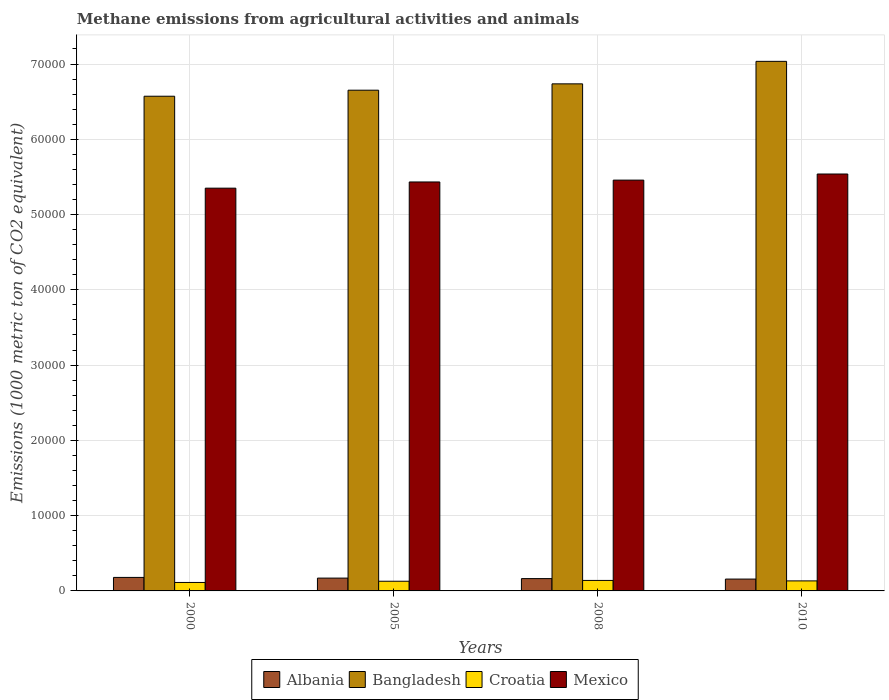How many different coloured bars are there?
Offer a terse response. 4. Are the number of bars per tick equal to the number of legend labels?
Your response must be concise. Yes. How many bars are there on the 1st tick from the left?
Make the answer very short. 4. How many bars are there on the 1st tick from the right?
Make the answer very short. 4. What is the label of the 4th group of bars from the left?
Ensure brevity in your answer.  2010. What is the amount of methane emitted in Croatia in 2005?
Your answer should be very brief. 1285.2. Across all years, what is the maximum amount of methane emitted in Croatia?
Offer a very short reply. 1392.8. Across all years, what is the minimum amount of methane emitted in Mexico?
Keep it short and to the point. 5.35e+04. In which year was the amount of methane emitted in Croatia maximum?
Your answer should be compact. 2008. In which year was the amount of methane emitted in Mexico minimum?
Keep it short and to the point. 2000. What is the total amount of methane emitted in Albania in the graph?
Offer a terse response. 6707.4. What is the difference between the amount of methane emitted in Croatia in 2008 and that in 2010?
Keep it short and to the point. 61.5. What is the difference between the amount of methane emitted in Mexico in 2008 and the amount of methane emitted in Bangladesh in 2010?
Your answer should be very brief. -1.58e+04. What is the average amount of methane emitted in Mexico per year?
Keep it short and to the point. 5.44e+04. In the year 2000, what is the difference between the amount of methane emitted in Croatia and amount of methane emitted in Mexico?
Give a very brief answer. -5.24e+04. In how many years, is the amount of methane emitted in Croatia greater than 36000 1000 metric ton?
Make the answer very short. 0. What is the ratio of the amount of methane emitted in Croatia in 2005 to that in 2010?
Your answer should be compact. 0.97. Is the amount of methane emitted in Croatia in 2000 less than that in 2008?
Your answer should be compact. Yes. What is the difference between the highest and the second highest amount of methane emitted in Bangladesh?
Your answer should be very brief. 2989. What is the difference between the highest and the lowest amount of methane emitted in Mexico?
Offer a very short reply. 1881.2. In how many years, is the amount of methane emitted in Croatia greater than the average amount of methane emitted in Croatia taken over all years?
Make the answer very short. 3. What does the 3rd bar from the left in 2008 represents?
Your answer should be compact. Croatia. What does the 3rd bar from the right in 2005 represents?
Make the answer very short. Bangladesh. Is it the case that in every year, the sum of the amount of methane emitted in Croatia and amount of methane emitted in Bangladesh is greater than the amount of methane emitted in Albania?
Your response must be concise. Yes. How many bars are there?
Provide a succinct answer. 16. How many years are there in the graph?
Your response must be concise. 4. Does the graph contain any zero values?
Offer a terse response. No. Does the graph contain grids?
Give a very brief answer. Yes. Where does the legend appear in the graph?
Make the answer very short. Bottom center. How many legend labels are there?
Ensure brevity in your answer.  4. What is the title of the graph?
Ensure brevity in your answer.  Methane emissions from agricultural activities and animals. Does "Burundi" appear as one of the legend labels in the graph?
Give a very brief answer. No. What is the label or title of the Y-axis?
Offer a very short reply. Emissions (1000 metric ton of CO2 equivalent). What is the Emissions (1000 metric ton of CO2 equivalent) in Albania in 2000?
Provide a short and direct response. 1794.6. What is the Emissions (1000 metric ton of CO2 equivalent) in Bangladesh in 2000?
Provide a short and direct response. 6.57e+04. What is the Emissions (1000 metric ton of CO2 equivalent) in Croatia in 2000?
Provide a short and direct response. 1124.5. What is the Emissions (1000 metric ton of CO2 equivalent) in Mexico in 2000?
Your answer should be compact. 5.35e+04. What is the Emissions (1000 metric ton of CO2 equivalent) of Albania in 2005?
Offer a very short reply. 1702.9. What is the Emissions (1000 metric ton of CO2 equivalent) of Bangladesh in 2005?
Your response must be concise. 6.65e+04. What is the Emissions (1000 metric ton of CO2 equivalent) in Croatia in 2005?
Make the answer very short. 1285.2. What is the Emissions (1000 metric ton of CO2 equivalent) in Mexico in 2005?
Give a very brief answer. 5.43e+04. What is the Emissions (1000 metric ton of CO2 equivalent) of Albania in 2008?
Offer a terse response. 1635.8. What is the Emissions (1000 metric ton of CO2 equivalent) of Bangladesh in 2008?
Provide a short and direct response. 6.74e+04. What is the Emissions (1000 metric ton of CO2 equivalent) of Croatia in 2008?
Offer a very short reply. 1392.8. What is the Emissions (1000 metric ton of CO2 equivalent) of Mexico in 2008?
Your answer should be very brief. 5.46e+04. What is the Emissions (1000 metric ton of CO2 equivalent) of Albania in 2010?
Provide a succinct answer. 1574.1. What is the Emissions (1000 metric ton of CO2 equivalent) of Bangladesh in 2010?
Ensure brevity in your answer.  7.04e+04. What is the Emissions (1000 metric ton of CO2 equivalent) of Croatia in 2010?
Offer a very short reply. 1331.3. What is the Emissions (1000 metric ton of CO2 equivalent) in Mexico in 2010?
Make the answer very short. 5.54e+04. Across all years, what is the maximum Emissions (1000 metric ton of CO2 equivalent) of Albania?
Your answer should be compact. 1794.6. Across all years, what is the maximum Emissions (1000 metric ton of CO2 equivalent) of Bangladesh?
Offer a terse response. 7.04e+04. Across all years, what is the maximum Emissions (1000 metric ton of CO2 equivalent) in Croatia?
Give a very brief answer. 1392.8. Across all years, what is the maximum Emissions (1000 metric ton of CO2 equivalent) of Mexico?
Provide a succinct answer. 5.54e+04. Across all years, what is the minimum Emissions (1000 metric ton of CO2 equivalent) of Albania?
Offer a very short reply. 1574.1. Across all years, what is the minimum Emissions (1000 metric ton of CO2 equivalent) of Bangladesh?
Offer a very short reply. 6.57e+04. Across all years, what is the minimum Emissions (1000 metric ton of CO2 equivalent) of Croatia?
Offer a terse response. 1124.5. Across all years, what is the minimum Emissions (1000 metric ton of CO2 equivalent) in Mexico?
Offer a terse response. 5.35e+04. What is the total Emissions (1000 metric ton of CO2 equivalent) of Albania in the graph?
Provide a short and direct response. 6707.4. What is the total Emissions (1000 metric ton of CO2 equivalent) in Bangladesh in the graph?
Your response must be concise. 2.70e+05. What is the total Emissions (1000 metric ton of CO2 equivalent) of Croatia in the graph?
Ensure brevity in your answer.  5133.8. What is the total Emissions (1000 metric ton of CO2 equivalent) in Mexico in the graph?
Make the answer very short. 2.18e+05. What is the difference between the Emissions (1000 metric ton of CO2 equivalent) of Albania in 2000 and that in 2005?
Your answer should be very brief. 91.7. What is the difference between the Emissions (1000 metric ton of CO2 equivalent) in Bangladesh in 2000 and that in 2005?
Keep it short and to the point. -800.9. What is the difference between the Emissions (1000 metric ton of CO2 equivalent) in Croatia in 2000 and that in 2005?
Keep it short and to the point. -160.7. What is the difference between the Emissions (1000 metric ton of CO2 equivalent) of Mexico in 2000 and that in 2005?
Your answer should be compact. -824. What is the difference between the Emissions (1000 metric ton of CO2 equivalent) of Albania in 2000 and that in 2008?
Your response must be concise. 158.8. What is the difference between the Emissions (1000 metric ton of CO2 equivalent) in Bangladesh in 2000 and that in 2008?
Provide a short and direct response. -1643.5. What is the difference between the Emissions (1000 metric ton of CO2 equivalent) of Croatia in 2000 and that in 2008?
Keep it short and to the point. -268.3. What is the difference between the Emissions (1000 metric ton of CO2 equivalent) in Mexico in 2000 and that in 2008?
Make the answer very short. -1070.7. What is the difference between the Emissions (1000 metric ton of CO2 equivalent) in Albania in 2000 and that in 2010?
Provide a short and direct response. 220.5. What is the difference between the Emissions (1000 metric ton of CO2 equivalent) of Bangladesh in 2000 and that in 2010?
Offer a terse response. -4632.5. What is the difference between the Emissions (1000 metric ton of CO2 equivalent) in Croatia in 2000 and that in 2010?
Ensure brevity in your answer.  -206.8. What is the difference between the Emissions (1000 metric ton of CO2 equivalent) in Mexico in 2000 and that in 2010?
Offer a terse response. -1881.2. What is the difference between the Emissions (1000 metric ton of CO2 equivalent) of Albania in 2005 and that in 2008?
Make the answer very short. 67.1. What is the difference between the Emissions (1000 metric ton of CO2 equivalent) in Bangladesh in 2005 and that in 2008?
Offer a terse response. -842.6. What is the difference between the Emissions (1000 metric ton of CO2 equivalent) in Croatia in 2005 and that in 2008?
Offer a very short reply. -107.6. What is the difference between the Emissions (1000 metric ton of CO2 equivalent) in Mexico in 2005 and that in 2008?
Give a very brief answer. -246.7. What is the difference between the Emissions (1000 metric ton of CO2 equivalent) of Albania in 2005 and that in 2010?
Provide a succinct answer. 128.8. What is the difference between the Emissions (1000 metric ton of CO2 equivalent) of Bangladesh in 2005 and that in 2010?
Give a very brief answer. -3831.6. What is the difference between the Emissions (1000 metric ton of CO2 equivalent) of Croatia in 2005 and that in 2010?
Offer a very short reply. -46.1. What is the difference between the Emissions (1000 metric ton of CO2 equivalent) in Mexico in 2005 and that in 2010?
Keep it short and to the point. -1057.2. What is the difference between the Emissions (1000 metric ton of CO2 equivalent) of Albania in 2008 and that in 2010?
Your answer should be compact. 61.7. What is the difference between the Emissions (1000 metric ton of CO2 equivalent) of Bangladesh in 2008 and that in 2010?
Your response must be concise. -2989. What is the difference between the Emissions (1000 metric ton of CO2 equivalent) in Croatia in 2008 and that in 2010?
Ensure brevity in your answer.  61.5. What is the difference between the Emissions (1000 metric ton of CO2 equivalent) of Mexico in 2008 and that in 2010?
Your response must be concise. -810.5. What is the difference between the Emissions (1000 metric ton of CO2 equivalent) in Albania in 2000 and the Emissions (1000 metric ton of CO2 equivalent) in Bangladesh in 2005?
Your response must be concise. -6.47e+04. What is the difference between the Emissions (1000 metric ton of CO2 equivalent) of Albania in 2000 and the Emissions (1000 metric ton of CO2 equivalent) of Croatia in 2005?
Provide a short and direct response. 509.4. What is the difference between the Emissions (1000 metric ton of CO2 equivalent) of Albania in 2000 and the Emissions (1000 metric ton of CO2 equivalent) of Mexico in 2005?
Provide a short and direct response. -5.25e+04. What is the difference between the Emissions (1000 metric ton of CO2 equivalent) of Bangladesh in 2000 and the Emissions (1000 metric ton of CO2 equivalent) of Croatia in 2005?
Your answer should be very brief. 6.44e+04. What is the difference between the Emissions (1000 metric ton of CO2 equivalent) of Bangladesh in 2000 and the Emissions (1000 metric ton of CO2 equivalent) of Mexico in 2005?
Keep it short and to the point. 1.14e+04. What is the difference between the Emissions (1000 metric ton of CO2 equivalent) in Croatia in 2000 and the Emissions (1000 metric ton of CO2 equivalent) in Mexico in 2005?
Give a very brief answer. -5.32e+04. What is the difference between the Emissions (1000 metric ton of CO2 equivalent) in Albania in 2000 and the Emissions (1000 metric ton of CO2 equivalent) in Bangladesh in 2008?
Your answer should be compact. -6.56e+04. What is the difference between the Emissions (1000 metric ton of CO2 equivalent) in Albania in 2000 and the Emissions (1000 metric ton of CO2 equivalent) in Croatia in 2008?
Ensure brevity in your answer.  401.8. What is the difference between the Emissions (1000 metric ton of CO2 equivalent) in Albania in 2000 and the Emissions (1000 metric ton of CO2 equivalent) in Mexico in 2008?
Keep it short and to the point. -5.28e+04. What is the difference between the Emissions (1000 metric ton of CO2 equivalent) of Bangladesh in 2000 and the Emissions (1000 metric ton of CO2 equivalent) of Croatia in 2008?
Offer a terse response. 6.43e+04. What is the difference between the Emissions (1000 metric ton of CO2 equivalent) of Bangladesh in 2000 and the Emissions (1000 metric ton of CO2 equivalent) of Mexico in 2008?
Offer a terse response. 1.11e+04. What is the difference between the Emissions (1000 metric ton of CO2 equivalent) of Croatia in 2000 and the Emissions (1000 metric ton of CO2 equivalent) of Mexico in 2008?
Make the answer very short. -5.35e+04. What is the difference between the Emissions (1000 metric ton of CO2 equivalent) in Albania in 2000 and the Emissions (1000 metric ton of CO2 equivalent) in Bangladesh in 2010?
Provide a short and direct response. -6.86e+04. What is the difference between the Emissions (1000 metric ton of CO2 equivalent) of Albania in 2000 and the Emissions (1000 metric ton of CO2 equivalent) of Croatia in 2010?
Provide a short and direct response. 463.3. What is the difference between the Emissions (1000 metric ton of CO2 equivalent) of Albania in 2000 and the Emissions (1000 metric ton of CO2 equivalent) of Mexico in 2010?
Offer a very short reply. -5.36e+04. What is the difference between the Emissions (1000 metric ton of CO2 equivalent) in Bangladesh in 2000 and the Emissions (1000 metric ton of CO2 equivalent) in Croatia in 2010?
Offer a terse response. 6.44e+04. What is the difference between the Emissions (1000 metric ton of CO2 equivalent) of Bangladesh in 2000 and the Emissions (1000 metric ton of CO2 equivalent) of Mexico in 2010?
Provide a short and direct response. 1.03e+04. What is the difference between the Emissions (1000 metric ton of CO2 equivalent) of Croatia in 2000 and the Emissions (1000 metric ton of CO2 equivalent) of Mexico in 2010?
Offer a very short reply. -5.43e+04. What is the difference between the Emissions (1000 metric ton of CO2 equivalent) in Albania in 2005 and the Emissions (1000 metric ton of CO2 equivalent) in Bangladesh in 2008?
Your response must be concise. -6.57e+04. What is the difference between the Emissions (1000 metric ton of CO2 equivalent) of Albania in 2005 and the Emissions (1000 metric ton of CO2 equivalent) of Croatia in 2008?
Ensure brevity in your answer.  310.1. What is the difference between the Emissions (1000 metric ton of CO2 equivalent) in Albania in 2005 and the Emissions (1000 metric ton of CO2 equivalent) in Mexico in 2008?
Give a very brief answer. -5.29e+04. What is the difference between the Emissions (1000 metric ton of CO2 equivalent) in Bangladesh in 2005 and the Emissions (1000 metric ton of CO2 equivalent) in Croatia in 2008?
Your answer should be very brief. 6.51e+04. What is the difference between the Emissions (1000 metric ton of CO2 equivalent) in Bangladesh in 2005 and the Emissions (1000 metric ton of CO2 equivalent) in Mexico in 2008?
Your answer should be compact. 1.19e+04. What is the difference between the Emissions (1000 metric ton of CO2 equivalent) in Croatia in 2005 and the Emissions (1000 metric ton of CO2 equivalent) in Mexico in 2008?
Offer a very short reply. -5.33e+04. What is the difference between the Emissions (1000 metric ton of CO2 equivalent) in Albania in 2005 and the Emissions (1000 metric ton of CO2 equivalent) in Bangladesh in 2010?
Offer a very short reply. -6.87e+04. What is the difference between the Emissions (1000 metric ton of CO2 equivalent) of Albania in 2005 and the Emissions (1000 metric ton of CO2 equivalent) of Croatia in 2010?
Ensure brevity in your answer.  371.6. What is the difference between the Emissions (1000 metric ton of CO2 equivalent) of Albania in 2005 and the Emissions (1000 metric ton of CO2 equivalent) of Mexico in 2010?
Offer a terse response. -5.37e+04. What is the difference between the Emissions (1000 metric ton of CO2 equivalent) of Bangladesh in 2005 and the Emissions (1000 metric ton of CO2 equivalent) of Croatia in 2010?
Ensure brevity in your answer.  6.52e+04. What is the difference between the Emissions (1000 metric ton of CO2 equivalent) in Bangladesh in 2005 and the Emissions (1000 metric ton of CO2 equivalent) in Mexico in 2010?
Keep it short and to the point. 1.11e+04. What is the difference between the Emissions (1000 metric ton of CO2 equivalent) of Croatia in 2005 and the Emissions (1000 metric ton of CO2 equivalent) of Mexico in 2010?
Your answer should be compact. -5.41e+04. What is the difference between the Emissions (1000 metric ton of CO2 equivalent) in Albania in 2008 and the Emissions (1000 metric ton of CO2 equivalent) in Bangladesh in 2010?
Provide a short and direct response. -6.87e+04. What is the difference between the Emissions (1000 metric ton of CO2 equivalent) in Albania in 2008 and the Emissions (1000 metric ton of CO2 equivalent) in Croatia in 2010?
Provide a succinct answer. 304.5. What is the difference between the Emissions (1000 metric ton of CO2 equivalent) of Albania in 2008 and the Emissions (1000 metric ton of CO2 equivalent) of Mexico in 2010?
Keep it short and to the point. -5.38e+04. What is the difference between the Emissions (1000 metric ton of CO2 equivalent) in Bangladesh in 2008 and the Emissions (1000 metric ton of CO2 equivalent) in Croatia in 2010?
Your response must be concise. 6.60e+04. What is the difference between the Emissions (1000 metric ton of CO2 equivalent) of Bangladesh in 2008 and the Emissions (1000 metric ton of CO2 equivalent) of Mexico in 2010?
Make the answer very short. 1.20e+04. What is the difference between the Emissions (1000 metric ton of CO2 equivalent) in Croatia in 2008 and the Emissions (1000 metric ton of CO2 equivalent) in Mexico in 2010?
Provide a short and direct response. -5.40e+04. What is the average Emissions (1000 metric ton of CO2 equivalent) in Albania per year?
Make the answer very short. 1676.85. What is the average Emissions (1000 metric ton of CO2 equivalent) in Bangladesh per year?
Your answer should be compact. 6.75e+04. What is the average Emissions (1000 metric ton of CO2 equivalent) in Croatia per year?
Offer a terse response. 1283.45. What is the average Emissions (1000 metric ton of CO2 equivalent) of Mexico per year?
Your response must be concise. 5.44e+04. In the year 2000, what is the difference between the Emissions (1000 metric ton of CO2 equivalent) in Albania and Emissions (1000 metric ton of CO2 equivalent) in Bangladesh?
Ensure brevity in your answer.  -6.39e+04. In the year 2000, what is the difference between the Emissions (1000 metric ton of CO2 equivalent) of Albania and Emissions (1000 metric ton of CO2 equivalent) of Croatia?
Provide a succinct answer. 670.1. In the year 2000, what is the difference between the Emissions (1000 metric ton of CO2 equivalent) of Albania and Emissions (1000 metric ton of CO2 equivalent) of Mexico?
Ensure brevity in your answer.  -5.17e+04. In the year 2000, what is the difference between the Emissions (1000 metric ton of CO2 equivalent) in Bangladesh and Emissions (1000 metric ton of CO2 equivalent) in Croatia?
Your answer should be compact. 6.46e+04. In the year 2000, what is the difference between the Emissions (1000 metric ton of CO2 equivalent) in Bangladesh and Emissions (1000 metric ton of CO2 equivalent) in Mexico?
Ensure brevity in your answer.  1.22e+04. In the year 2000, what is the difference between the Emissions (1000 metric ton of CO2 equivalent) in Croatia and Emissions (1000 metric ton of CO2 equivalent) in Mexico?
Your response must be concise. -5.24e+04. In the year 2005, what is the difference between the Emissions (1000 metric ton of CO2 equivalent) in Albania and Emissions (1000 metric ton of CO2 equivalent) in Bangladesh?
Make the answer very short. -6.48e+04. In the year 2005, what is the difference between the Emissions (1000 metric ton of CO2 equivalent) in Albania and Emissions (1000 metric ton of CO2 equivalent) in Croatia?
Offer a very short reply. 417.7. In the year 2005, what is the difference between the Emissions (1000 metric ton of CO2 equivalent) in Albania and Emissions (1000 metric ton of CO2 equivalent) in Mexico?
Offer a terse response. -5.26e+04. In the year 2005, what is the difference between the Emissions (1000 metric ton of CO2 equivalent) in Bangladesh and Emissions (1000 metric ton of CO2 equivalent) in Croatia?
Ensure brevity in your answer.  6.52e+04. In the year 2005, what is the difference between the Emissions (1000 metric ton of CO2 equivalent) in Bangladesh and Emissions (1000 metric ton of CO2 equivalent) in Mexico?
Make the answer very short. 1.22e+04. In the year 2005, what is the difference between the Emissions (1000 metric ton of CO2 equivalent) of Croatia and Emissions (1000 metric ton of CO2 equivalent) of Mexico?
Offer a very short reply. -5.30e+04. In the year 2008, what is the difference between the Emissions (1000 metric ton of CO2 equivalent) of Albania and Emissions (1000 metric ton of CO2 equivalent) of Bangladesh?
Ensure brevity in your answer.  -6.57e+04. In the year 2008, what is the difference between the Emissions (1000 metric ton of CO2 equivalent) in Albania and Emissions (1000 metric ton of CO2 equivalent) in Croatia?
Your answer should be very brief. 243. In the year 2008, what is the difference between the Emissions (1000 metric ton of CO2 equivalent) in Albania and Emissions (1000 metric ton of CO2 equivalent) in Mexico?
Make the answer very short. -5.29e+04. In the year 2008, what is the difference between the Emissions (1000 metric ton of CO2 equivalent) in Bangladesh and Emissions (1000 metric ton of CO2 equivalent) in Croatia?
Your response must be concise. 6.60e+04. In the year 2008, what is the difference between the Emissions (1000 metric ton of CO2 equivalent) of Bangladesh and Emissions (1000 metric ton of CO2 equivalent) of Mexico?
Offer a terse response. 1.28e+04. In the year 2008, what is the difference between the Emissions (1000 metric ton of CO2 equivalent) in Croatia and Emissions (1000 metric ton of CO2 equivalent) in Mexico?
Make the answer very short. -5.32e+04. In the year 2010, what is the difference between the Emissions (1000 metric ton of CO2 equivalent) of Albania and Emissions (1000 metric ton of CO2 equivalent) of Bangladesh?
Provide a succinct answer. -6.88e+04. In the year 2010, what is the difference between the Emissions (1000 metric ton of CO2 equivalent) in Albania and Emissions (1000 metric ton of CO2 equivalent) in Croatia?
Give a very brief answer. 242.8. In the year 2010, what is the difference between the Emissions (1000 metric ton of CO2 equivalent) in Albania and Emissions (1000 metric ton of CO2 equivalent) in Mexico?
Give a very brief answer. -5.38e+04. In the year 2010, what is the difference between the Emissions (1000 metric ton of CO2 equivalent) in Bangladesh and Emissions (1000 metric ton of CO2 equivalent) in Croatia?
Keep it short and to the point. 6.90e+04. In the year 2010, what is the difference between the Emissions (1000 metric ton of CO2 equivalent) in Bangladesh and Emissions (1000 metric ton of CO2 equivalent) in Mexico?
Keep it short and to the point. 1.50e+04. In the year 2010, what is the difference between the Emissions (1000 metric ton of CO2 equivalent) in Croatia and Emissions (1000 metric ton of CO2 equivalent) in Mexico?
Your answer should be very brief. -5.41e+04. What is the ratio of the Emissions (1000 metric ton of CO2 equivalent) of Albania in 2000 to that in 2005?
Keep it short and to the point. 1.05. What is the ratio of the Emissions (1000 metric ton of CO2 equivalent) in Mexico in 2000 to that in 2005?
Provide a short and direct response. 0.98. What is the ratio of the Emissions (1000 metric ton of CO2 equivalent) of Albania in 2000 to that in 2008?
Your answer should be compact. 1.1. What is the ratio of the Emissions (1000 metric ton of CO2 equivalent) of Bangladesh in 2000 to that in 2008?
Provide a short and direct response. 0.98. What is the ratio of the Emissions (1000 metric ton of CO2 equivalent) of Croatia in 2000 to that in 2008?
Offer a terse response. 0.81. What is the ratio of the Emissions (1000 metric ton of CO2 equivalent) of Mexico in 2000 to that in 2008?
Offer a terse response. 0.98. What is the ratio of the Emissions (1000 metric ton of CO2 equivalent) of Albania in 2000 to that in 2010?
Offer a very short reply. 1.14. What is the ratio of the Emissions (1000 metric ton of CO2 equivalent) in Bangladesh in 2000 to that in 2010?
Your answer should be very brief. 0.93. What is the ratio of the Emissions (1000 metric ton of CO2 equivalent) in Croatia in 2000 to that in 2010?
Provide a short and direct response. 0.84. What is the ratio of the Emissions (1000 metric ton of CO2 equivalent) in Albania in 2005 to that in 2008?
Ensure brevity in your answer.  1.04. What is the ratio of the Emissions (1000 metric ton of CO2 equivalent) in Bangladesh in 2005 to that in 2008?
Offer a terse response. 0.99. What is the ratio of the Emissions (1000 metric ton of CO2 equivalent) of Croatia in 2005 to that in 2008?
Your response must be concise. 0.92. What is the ratio of the Emissions (1000 metric ton of CO2 equivalent) in Mexico in 2005 to that in 2008?
Ensure brevity in your answer.  1. What is the ratio of the Emissions (1000 metric ton of CO2 equivalent) in Albania in 2005 to that in 2010?
Offer a terse response. 1.08. What is the ratio of the Emissions (1000 metric ton of CO2 equivalent) in Bangladesh in 2005 to that in 2010?
Give a very brief answer. 0.95. What is the ratio of the Emissions (1000 metric ton of CO2 equivalent) in Croatia in 2005 to that in 2010?
Provide a succinct answer. 0.97. What is the ratio of the Emissions (1000 metric ton of CO2 equivalent) of Mexico in 2005 to that in 2010?
Your response must be concise. 0.98. What is the ratio of the Emissions (1000 metric ton of CO2 equivalent) in Albania in 2008 to that in 2010?
Make the answer very short. 1.04. What is the ratio of the Emissions (1000 metric ton of CO2 equivalent) in Bangladesh in 2008 to that in 2010?
Offer a terse response. 0.96. What is the ratio of the Emissions (1000 metric ton of CO2 equivalent) in Croatia in 2008 to that in 2010?
Offer a very short reply. 1.05. What is the ratio of the Emissions (1000 metric ton of CO2 equivalent) in Mexico in 2008 to that in 2010?
Your answer should be compact. 0.99. What is the difference between the highest and the second highest Emissions (1000 metric ton of CO2 equivalent) of Albania?
Provide a succinct answer. 91.7. What is the difference between the highest and the second highest Emissions (1000 metric ton of CO2 equivalent) in Bangladesh?
Provide a short and direct response. 2989. What is the difference between the highest and the second highest Emissions (1000 metric ton of CO2 equivalent) in Croatia?
Keep it short and to the point. 61.5. What is the difference between the highest and the second highest Emissions (1000 metric ton of CO2 equivalent) of Mexico?
Your response must be concise. 810.5. What is the difference between the highest and the lowest Emissions (1000 metric ton of CO2 equivalent) of Albania?
Your response must be concise. 220.5. What is the difference between the highest and the lowest Emissions (1000 metric ton of CO2 equivalent) in Bangladesh?
Ensure brevity in your answer.  4632.5. What is the difference between the highest and the lowest Emissions (1000 metric ton of CO2 equivalent) of Croatia?
Offer a very short reply. 268.3. What is the difference between the highest and the lowest Emissions (1000 metric ton of CO2 equivalent) of Mexico?
Provide a succinct answer. 1881.2. 